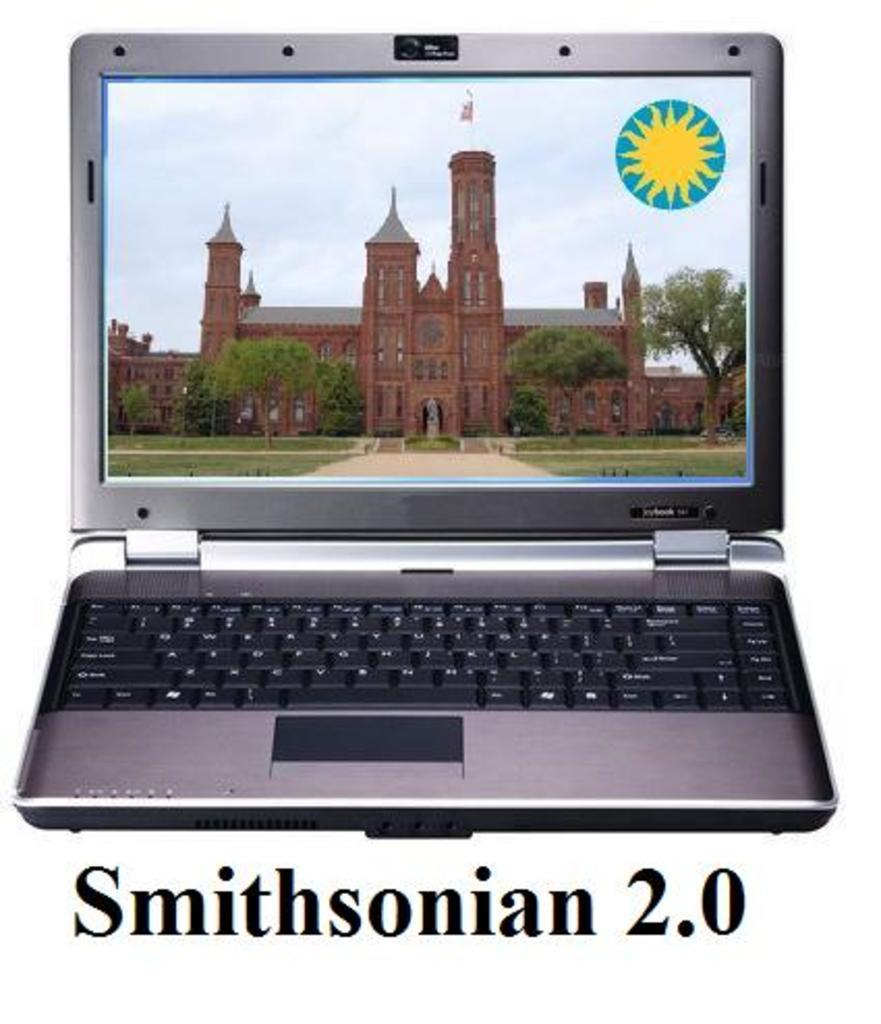<image>
Render a clear and concise summary of the photo. An open laptop with a large brick building displayed on the screen captioned "Smithsonian 2.0. 